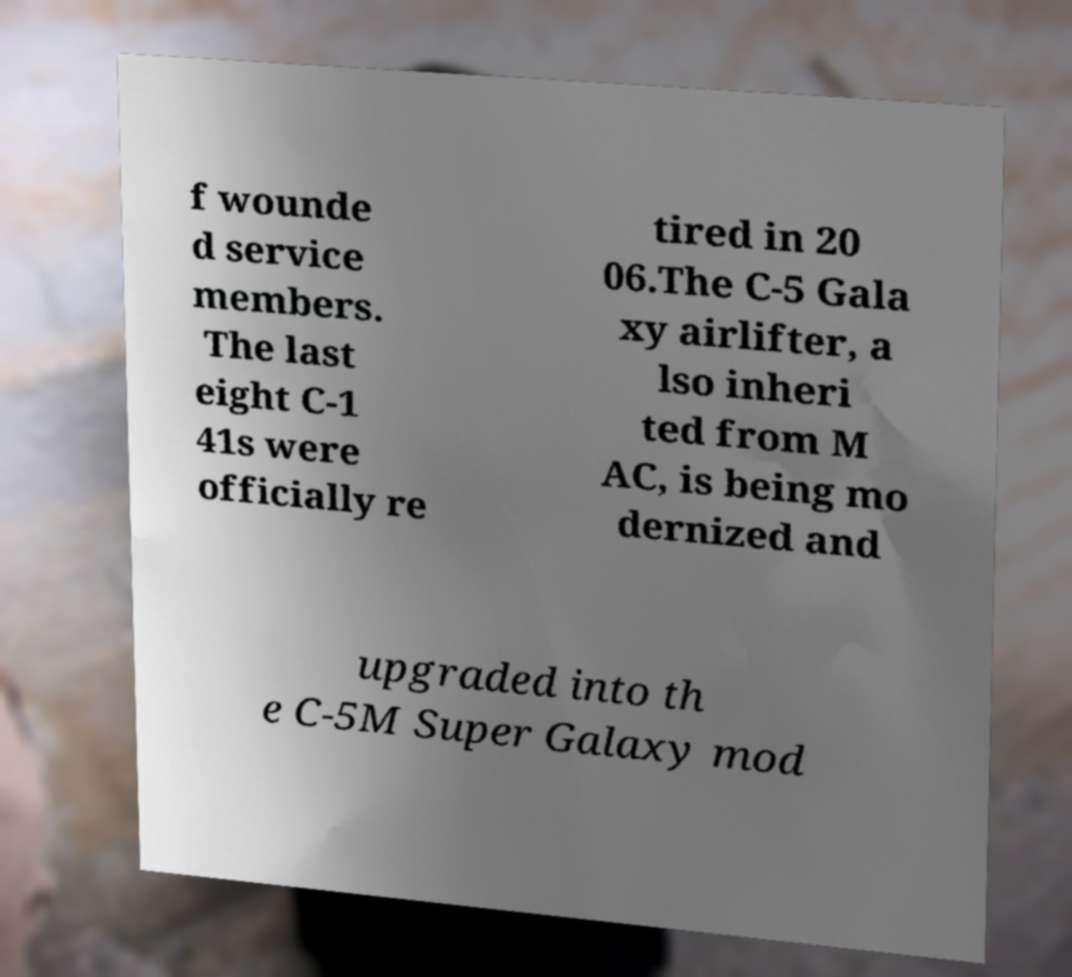What messages or text are displayed in this image? I need them in a readable, typed format. f wounde d service members. The last eight C-1 41s were officially re tired in 20 06.The C-5 Gala xy airlifter, a lso inheri ted from M AC, is being mo dernized and upgraded into th e C-5M Super Galaxy mod 